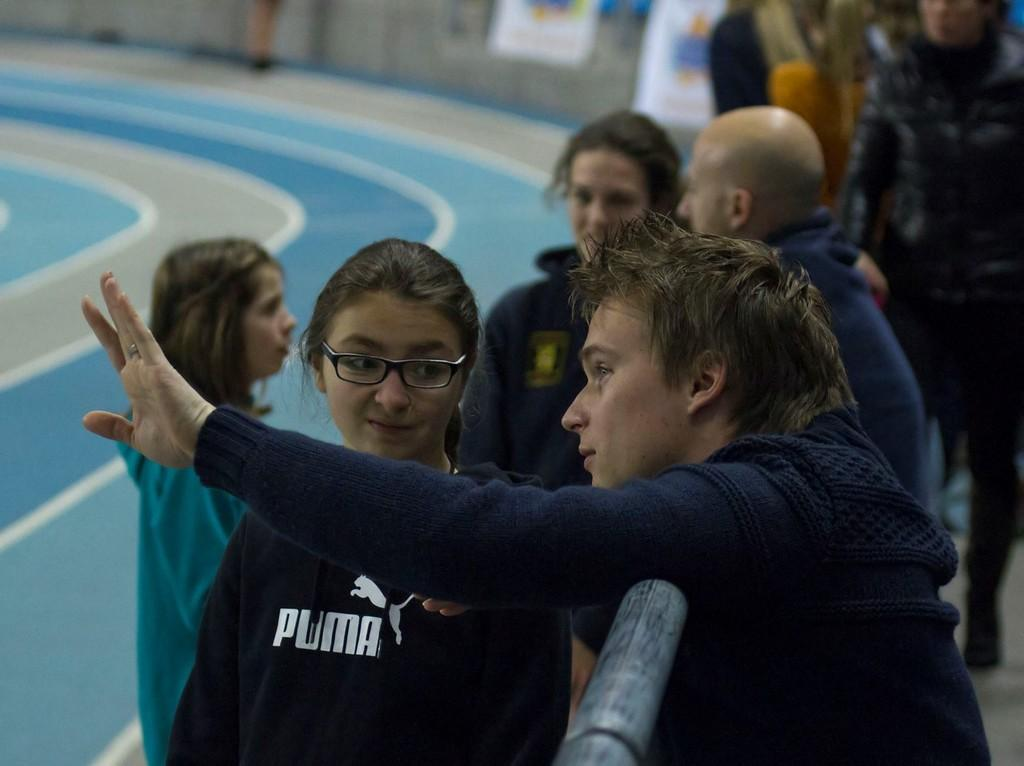How many people are visible in the image? There are many people standing in the image. What color are the dresses worn by the people in the image? The people are wearing blue color dresses. Can you describe the girl in the front? The girl in the front is wearing specs. What is on the left side of the image? There is a ground on the left side of the image. How would you describe the background of the image? The background of the image is blurred. Can you tell me how many bananas the girl in the front is biting in the image? There are no bananas present in the image, and therefore no such activity can be observed. 